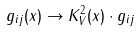Convert formula to latex. <formula><loc_0><loc_0><loc_500><loc_500>g _ { i j } ( x ) \rightarrow K _ { V } ^ { 2 } ( x ) \cdot g _ { i j }</formula> 